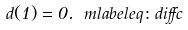<formula> <loc_0><loc_0><loc_500><loc_500>d ( 1 ) = 0 . \ m l a b e l { e q \colon d i f f c }</formula> 